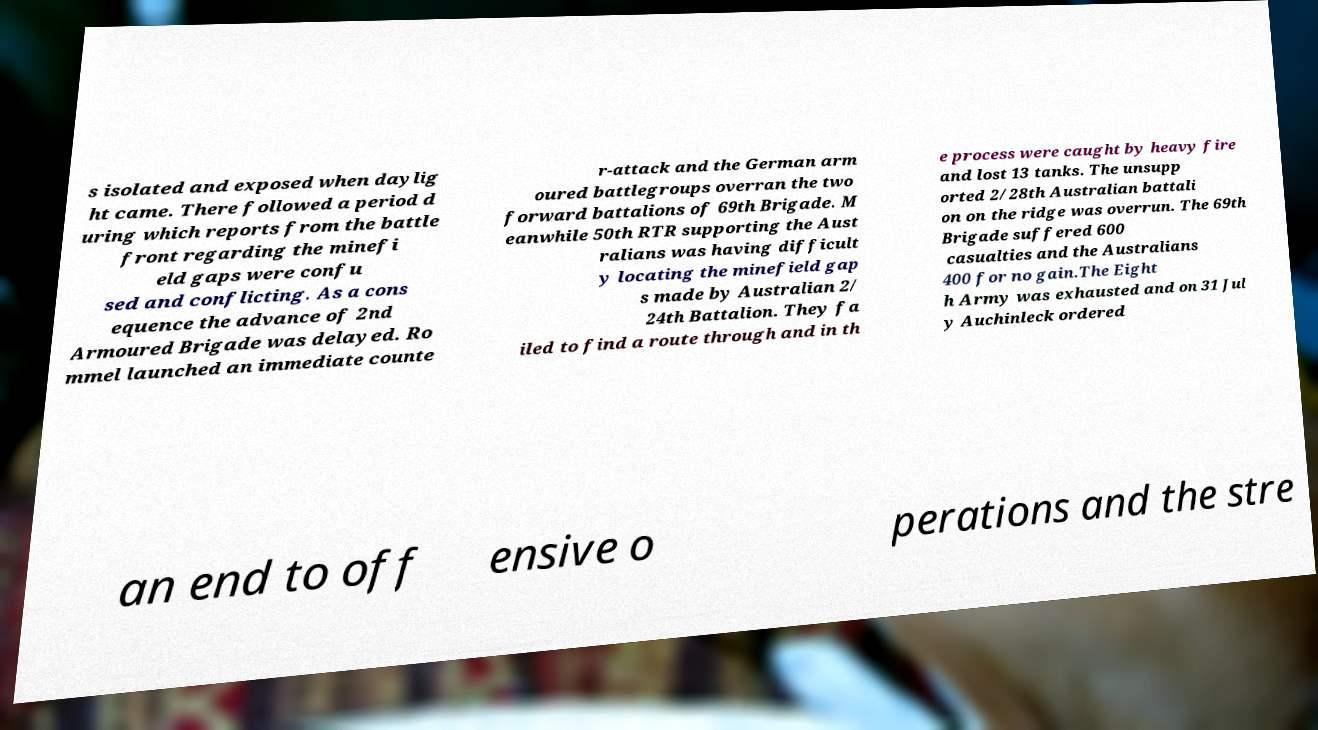Can you read and provide the text displayed in the image?This photo seems to have some interesting text. Can you extract and type it out for me? s isolated and exposed when daylig ht came. There followed a period d uring which reports from the battle front regarding the minefi eld gaps were confu sed and conflicting. As a cons equence the advance of 2nd Armoured Brigade was delayed. Ro mmel launched an immediate counte r-attack and the German arm oured battlegroups overran the two forward battalions of 69th Brigade. M eanwhile 50th RTR supporting the Aust ralians was having difficult y locating the minefield gap s made by Australian 2/ 24th Battalion. They fa iled to find a route through and in th e process were caught by heavy fire and lost 13 tanks. The unsupp orted 2/28th Australian battali on on the ridge was overrun. The 69th Brigade suffered 600 casualties and the Australians 400 for no gain.The Eight h Army was exhausted and on 31 Jul y Auchinleck ordered an end to off ensive o perations and the stre 